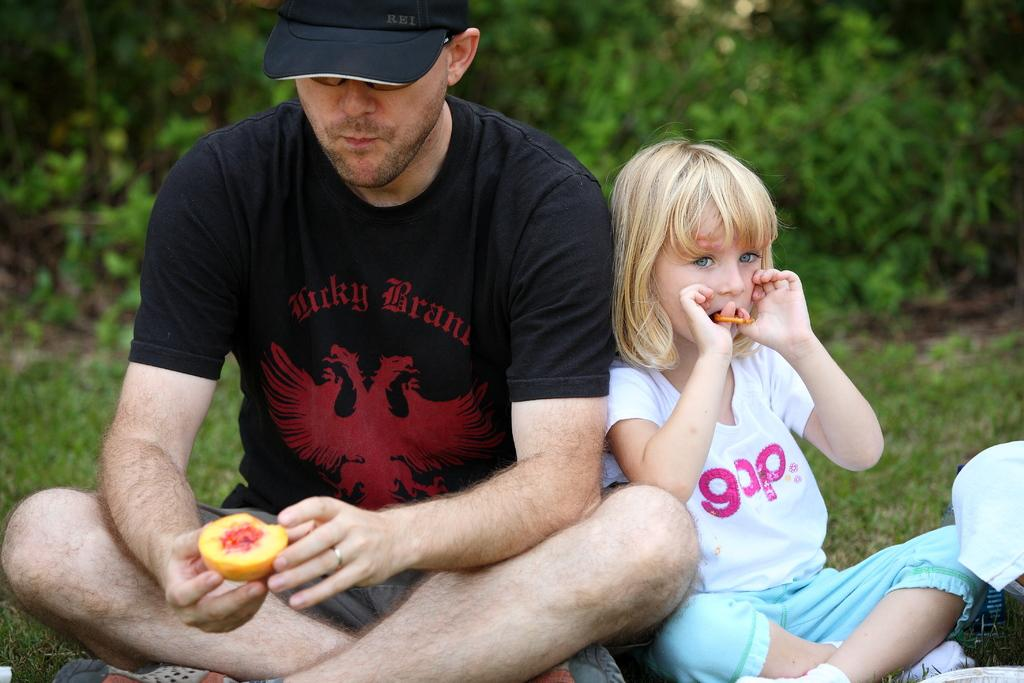Who are the people in the image? There is a man and a girl in the image. What are the man and the girl doing in the image? Both the man and the girl are seated on the grass. What is the man wearing on his head? The man is wearing a cap. What can be seen in the background of the image? There are trees in the background of the image. What type of guitar is the girl playing in the image? There is no guitar present in the image; the girl is not playing any instrument. What color is the crayon the man is holding in the image? There is no crayon present in the image; the man is not holding any drawing or writing utensil. 